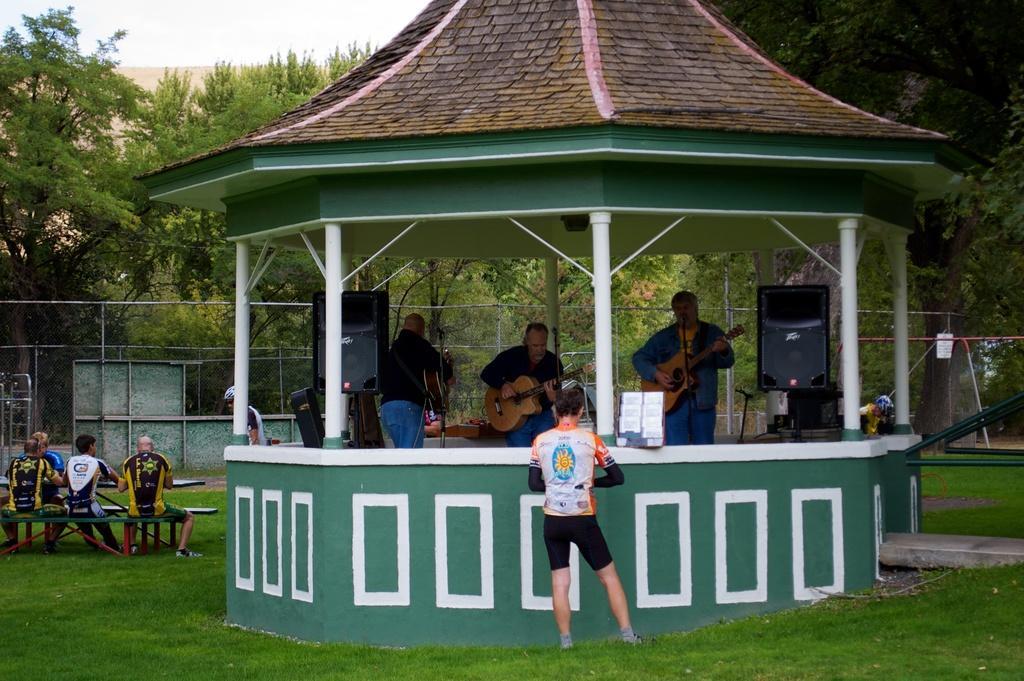Describe this image in one or two sentences. In this image there are group of persons who are in the hut playing musical instruments and at the foreground of the image there is a person standing and at the left side of the image there are persons sitting and at the background of the image there are trees. 